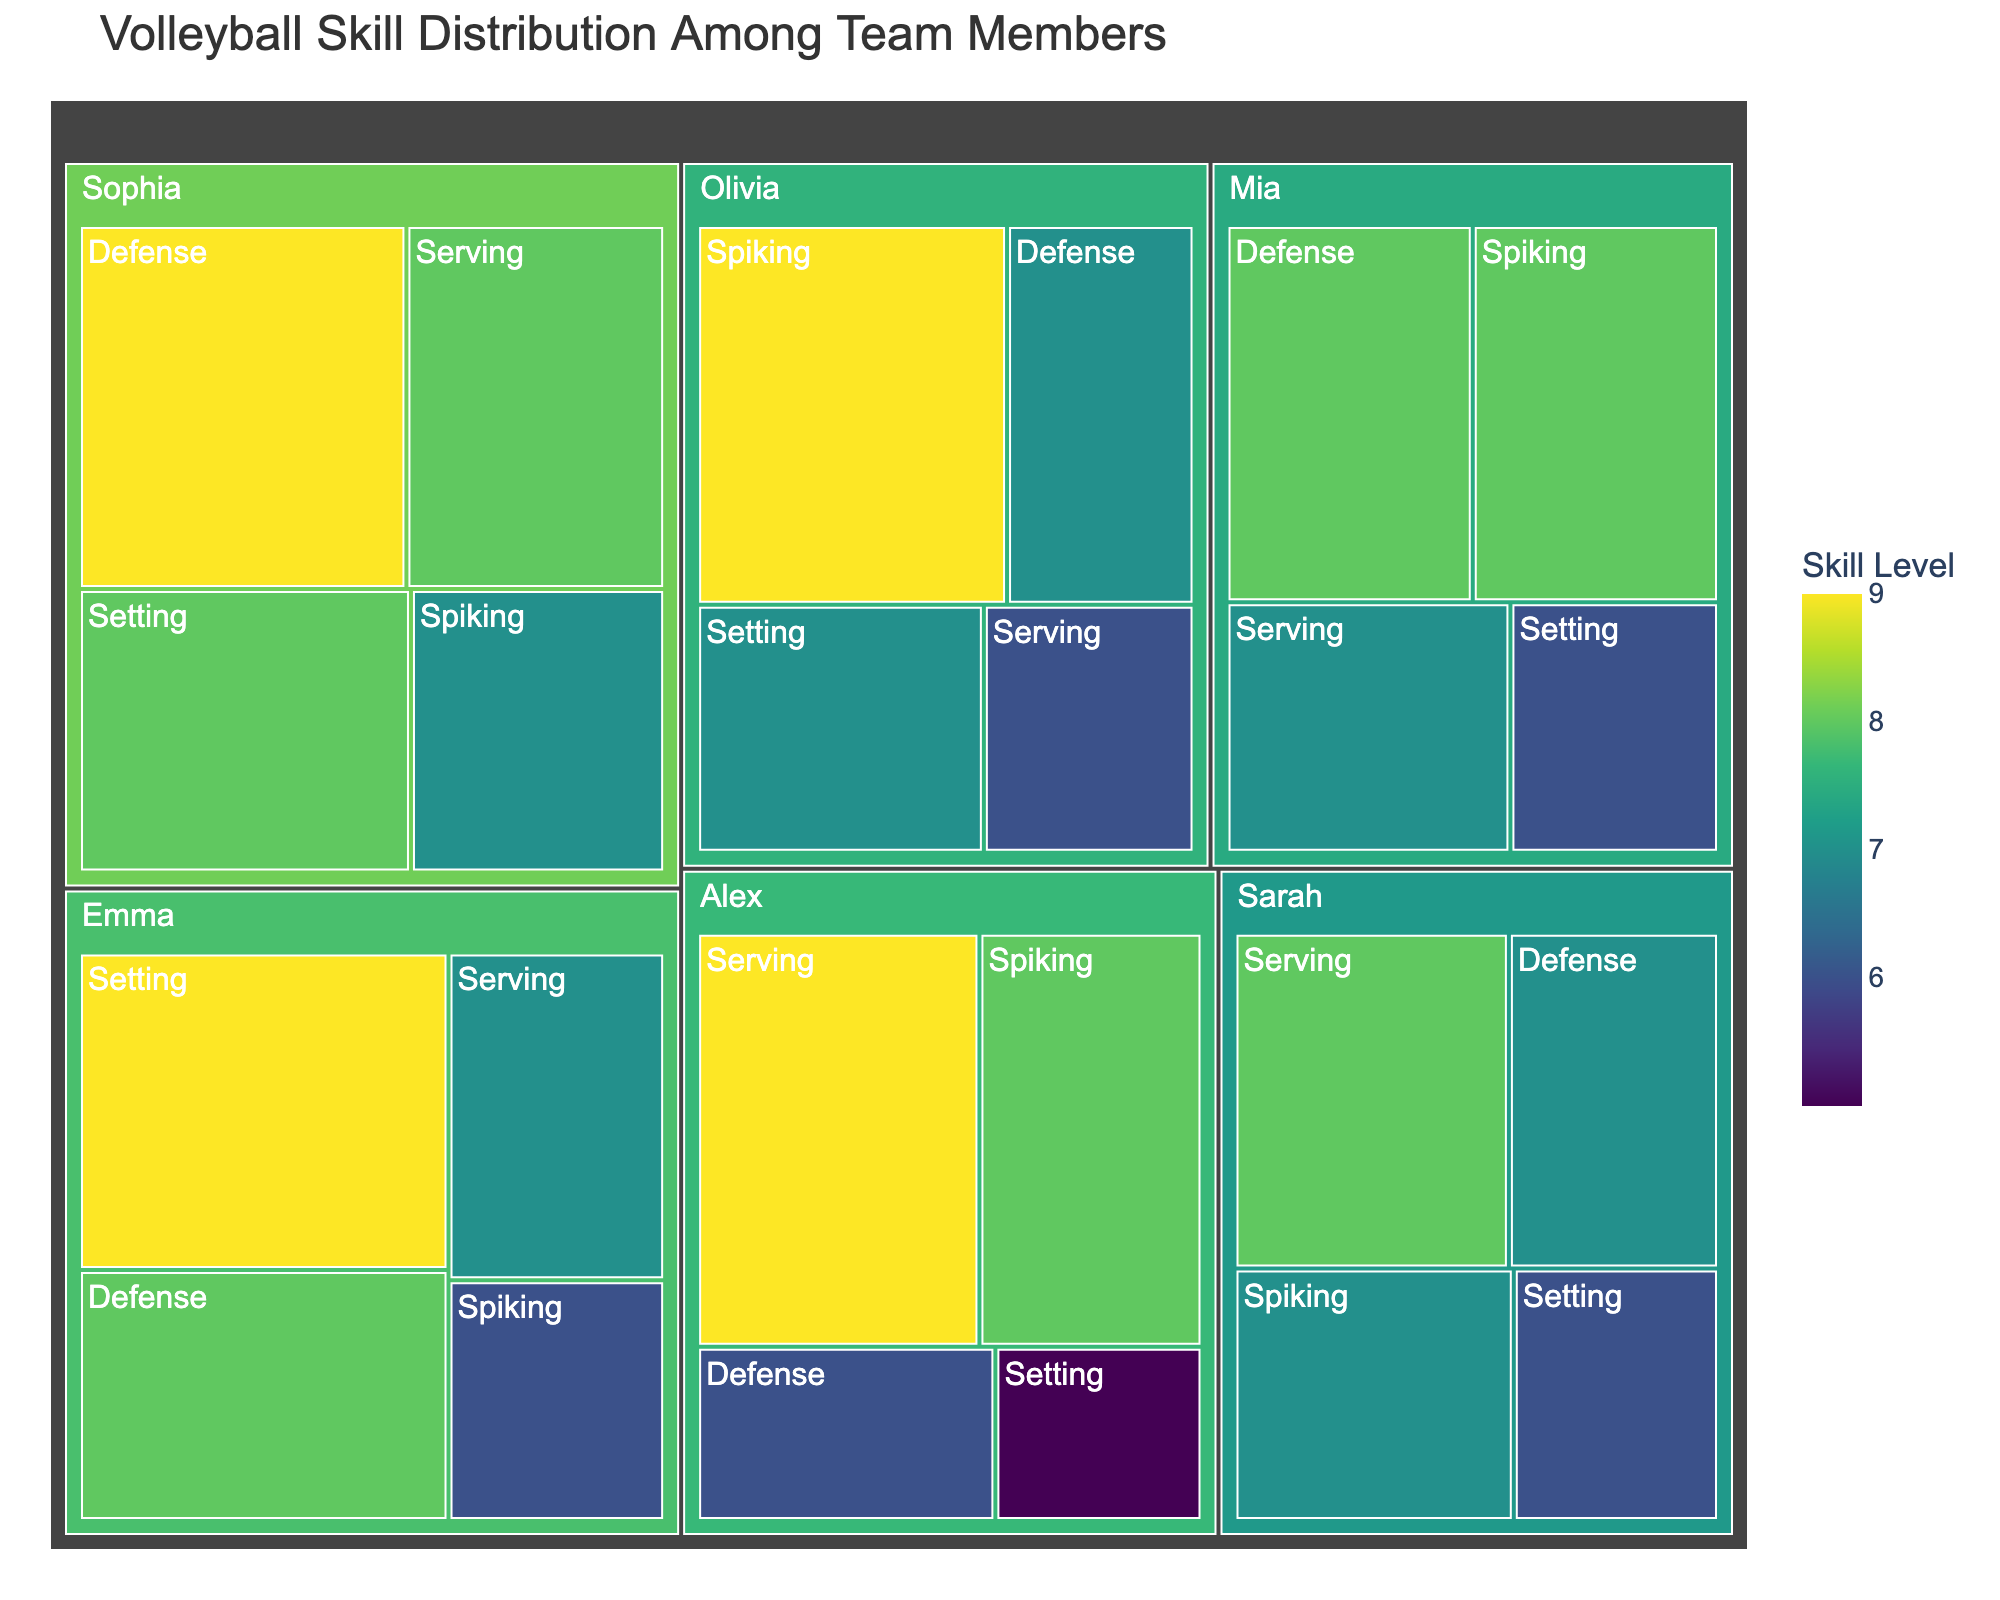What is the title of the figure? The title is located at the top of the treemap.
Answer: Volleyball Skill Distribution Among Team Members Which player has the highest skill level in the ‘Defense’ category? By examining the color intensity and the hover information in the treemap, Sophia’s defense skill level is the highest.
Answer: Sophia What is the sum of skill values for Emma? Emma’s skill values for Serving, Spiking, Setting, and Defense are 7, 6, 9, and 8 respectively. Summing these values: 7+6+9+8=30.
Answer: 30 Which skill does Olivia excel in? Looking at the color-coded areas under Olivia’s name and checking the hover information, Olivia’s highest skill level is 9 in Spiking.
Answer: Spiking Who has the lowest skill level in Setting, and what is the value? The lowest skill level in Setting can be found by comparing the color intensity and hover information for each player under the Setting category. It is Alex with a skill level of 5.
Answer: Alex, 5 Which player has the most balanced skill distribution across all four skills? A balanced skill distribution means having similar values within each skill category. By hovering over each player’s skills and comparing the values, Sarah shows the most balanced skills with values between 6 to 8 in all categories.
Answer: Sarah How many skills have a value of 9 for the entire team? By counting all instances where the skill value is 9 across the team's skills displayed on the treemap, we see there are 6 such instances.
Answer: 6 What is the average skill level for all players in the Spiking category? Adding up all Spiking skill values (7+8+6+9+7+8) gives 45. Dividing by the number of players (6) results in an average of 45/6=7.5.
Answer: 7.5 Which skill category has the highest average value across all players? Calculating the average for each skill category: Serving (8+9+7+6+8+7)/6 = 7.5, Spiking (7+8+6+9+7+8)/6 = 7.5, Setting (6+5+9+7+8+6)/6 = 6.833, Defense (7+6+8+7+9+8)/6 = 7.5. The highest average value is a tie between Serving, Spiking and Defense all at 7.5.
Answer: Serving, Spiking, Defense 